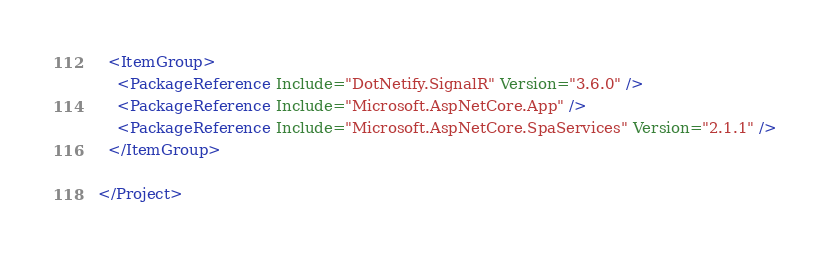Convert code to text. <code><loc_0><loc_0><loc_500><loc_500><_XML_>  <ItemGroup>
    <PackageReference Include="DotNetify.SignalR" Version="3.6.0" />
    <PackageReference Include="Microsoft.AspNetCore.App" />
    <PackageReference Include="Microsoft.AspNetCore.SpaServices" Version="2.1.1" />
  </ItemGroup>

</Project>
</code> 